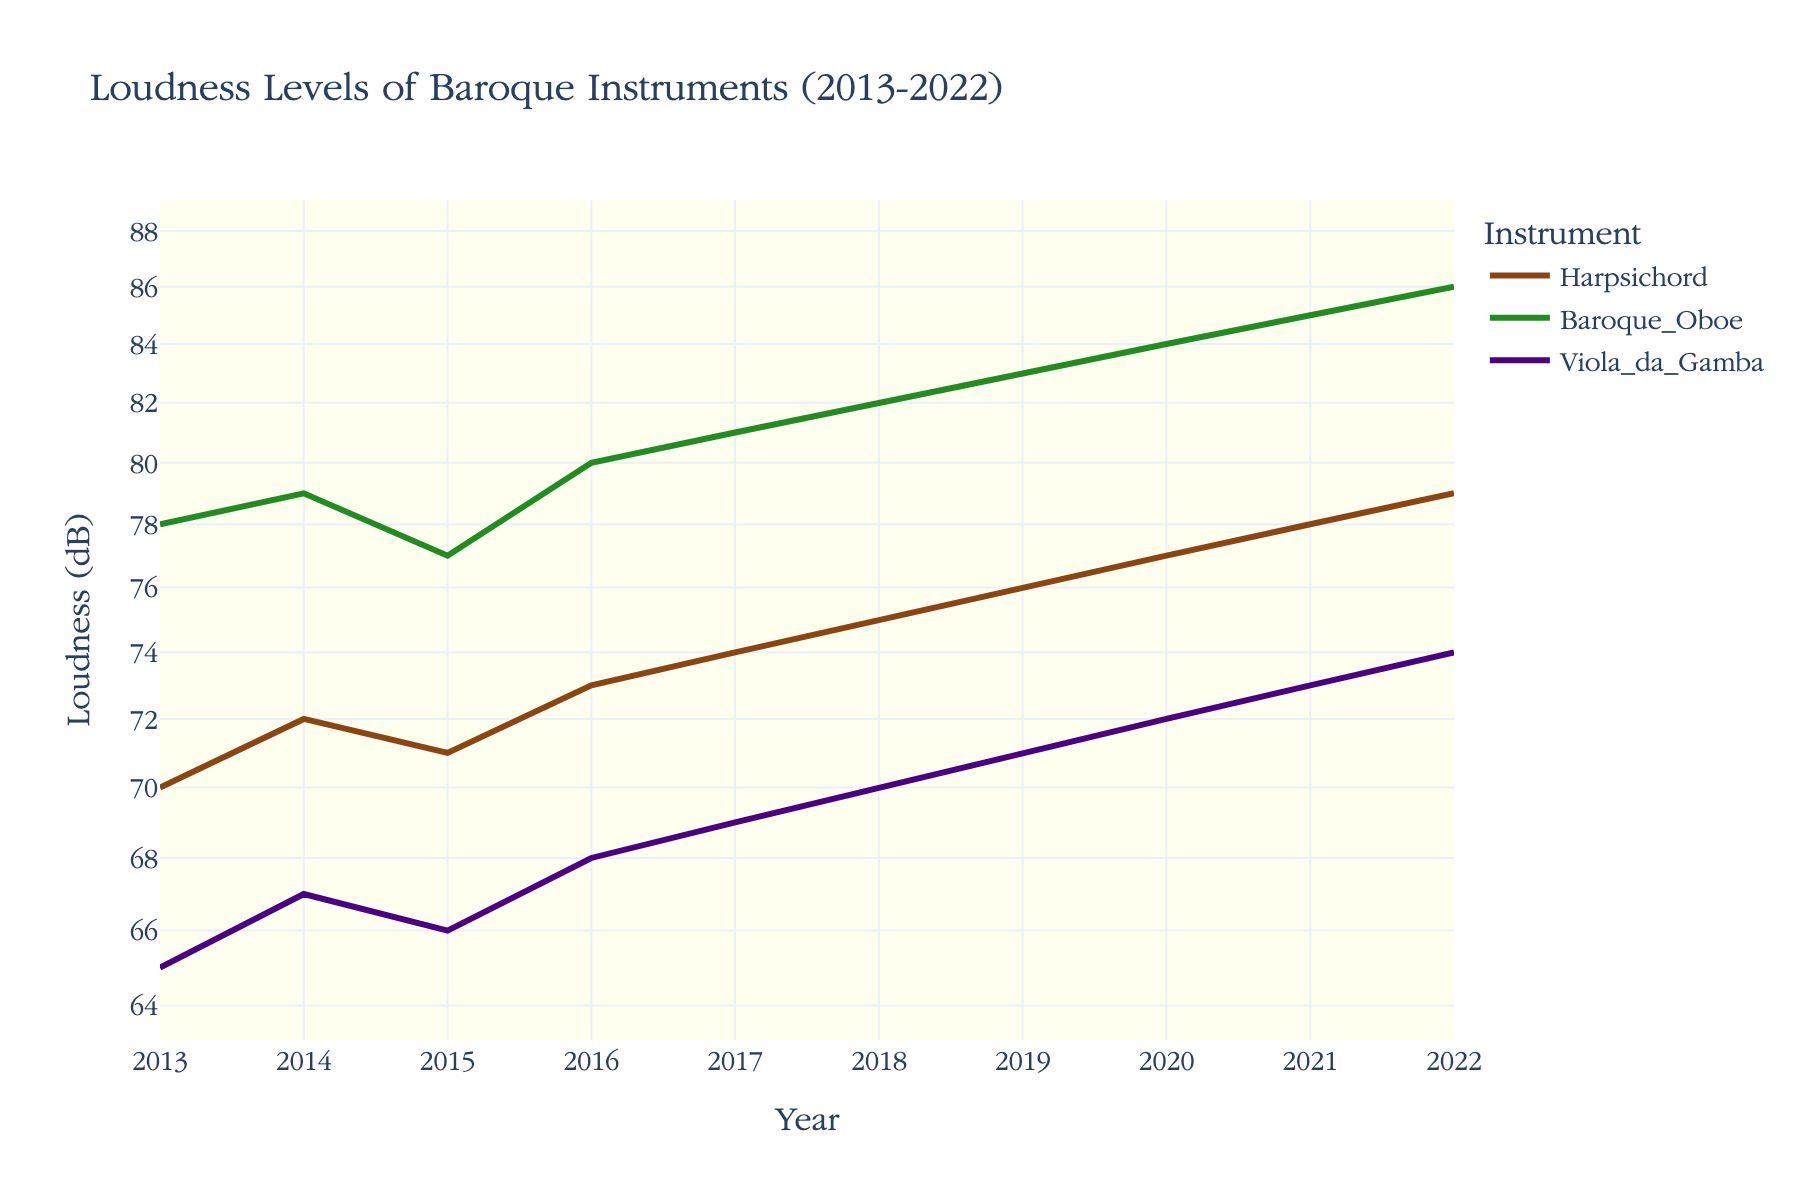What is the title of the figure? The title is usually placed at the top of the figure, indicating the subject matter. In this case, it is centered above the plot area.
Answer: Loudness Levels of Baroque Instruments (2013-2022) What are the instruments displayed in the figure? By examining the legend on the right side of the plot, you can see the labels and the corresponding colors for each instrument.
Answer: Harpsichord, Baroque Oboe, Viola da Gamba Which instrument had the highest loudness levels in 2022? The highest point on the right end of the plot, where the year is 2022, corresponds to the Baroque Oboe.
Answer: Baroque Oboe How did the loudness level of the Harpsichord change from 2013 to 2022? Look at the line for Harpsichord by following its color from 2013 to 2022. Observe the upward trend to estimate the change.
Answer: Increased from 70 dB to 79 dB Which year shows a noticeable annotation for improved restoration techniques? The annotation with explanatory text appears directly on the plot, near the midpoint of the x-axis.
Answer: 2017 How many data points are plotted for each instrument over the ten-year period? Count the number of points along the line for any single instrument, as each corresponds to a year. Since each year is plotted, there will be as many points as there are years.
Answer: 10 What is the approximate loudness level of the Viola da Gamba in 2018? Follow the line for Viola da Gamba to the year 2018, and check the y-axis value for this point.
Answer: 70 dB Compare the loudness levels of the Harpsichord and Baroque Oboe in 2015. Which one is quieter? Identify the points for both instruments in 2015, and compare their y-axis value.
Answer: Harpsichord What pattern do you observe in the loudness levels of Baroque Oboe over the years? Observe the line corresponding to Baroque Oboe, noting the general direction and any changes in slope over time.
Answer: Consistently increasing 